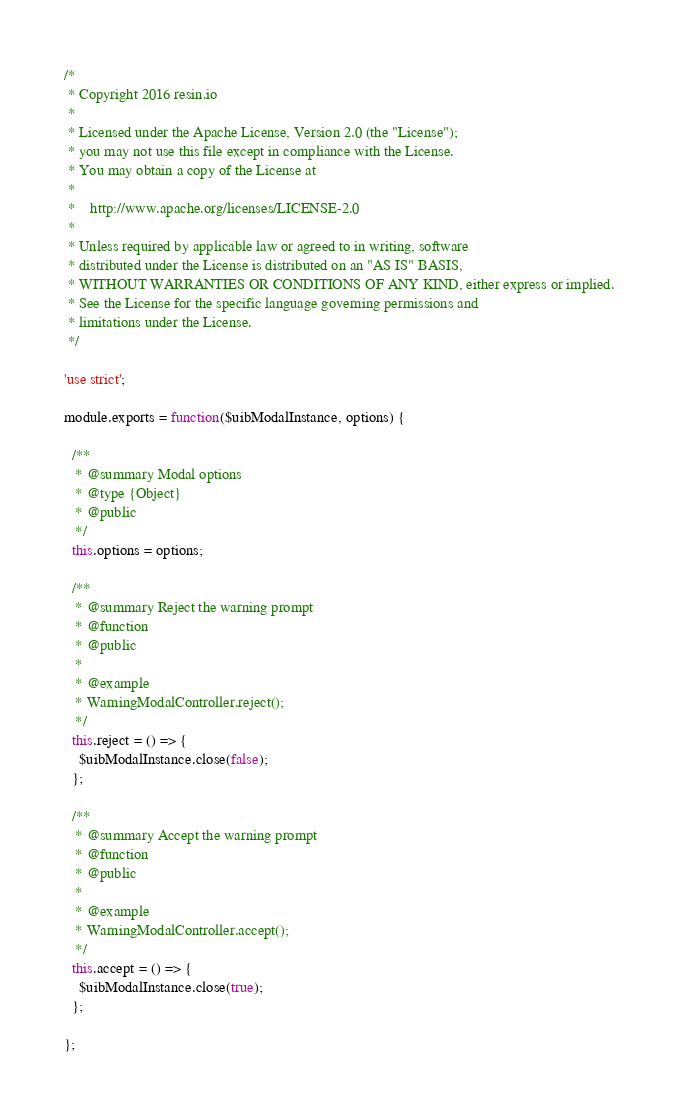<code> <loc_0><loc_0><loc_500><loc_500><_JavaScript_>/*
 * Copyright 2016 resin.io
 *
 * Licensed under the Apache License, Version 2.0 (the "License");
 * you may not use this file except in compliance with the License.
 * You may obtain a copy of the License at
 *
 *    http://www.apache.org/licenses/LICENSE-2.0
 *
 * Unless required by applicable law or agreed to in writing, software
 * distributed under the License is distributed on an "AS IS" BASIS,
 * WITHOUT WARRANTIES OR CONDITIONS OF ANY KIND, either express or implied.
 * See the License for the specific language governing permissions and
 * limitations under the License.
 */

'use strict';

module.exports = function($uibModalInstance, options) {

  /**
   * @summary Modal options
   * @type {Object}
   * @public
   */
  this.options = options;

  /**
   * @summary Reject the warning prompt
   * @function
   * @public
   *
   * @example
   * WarningModalController.reject();
   */
  this.reject = () => {
    $uibModalInstance.close(false);
  };

  /**
   * @summary Accept the warning prompt
   * @function
   * @public
   *
   * @example
   * WarningModalController.accept();
   */
  this.accept = () => {
    $uibModalInstance.close(true);
  };

};
</code> 